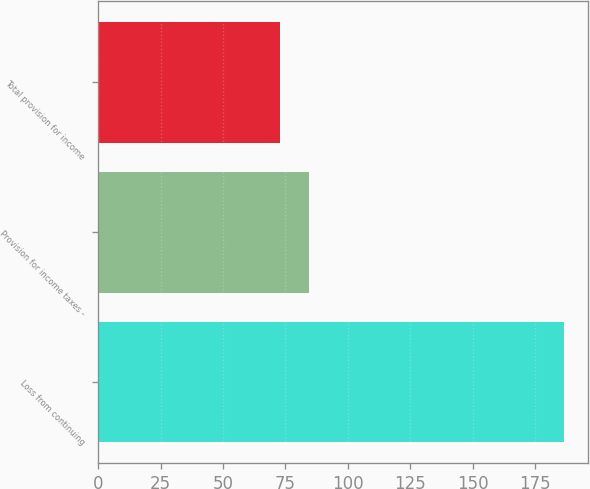Convert chart. <chart><loc_0><loc_0><loc_500><loc_500><bar_chart><fcel>Loss from continuing<fcel>Provision for income taxes -<fcel>Total provision for income<nl><fcel>186.6<fcel>84.27<fcel>72.9<nl></chart> 